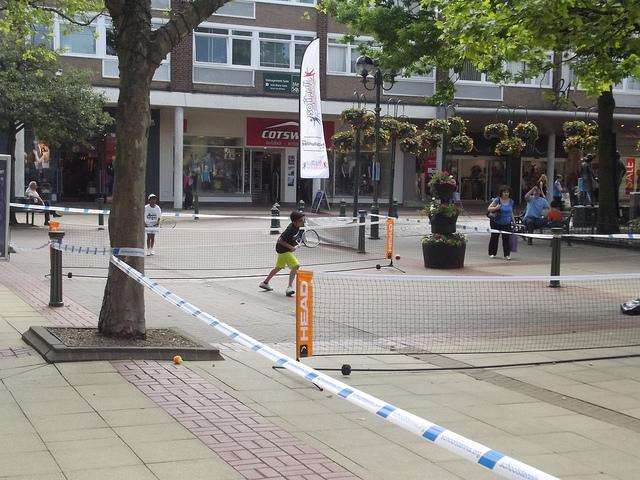Who is playing tennis with the boy wearing yellow pants?

Choices:
A) woman
B) young man
C) boy
D) old man woman 